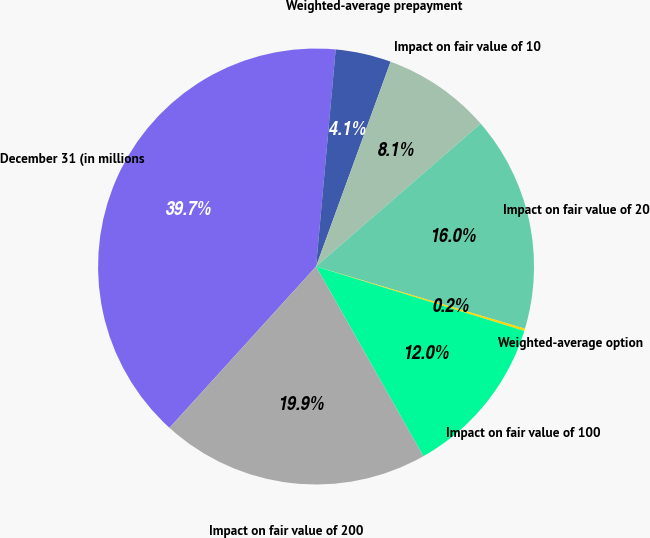Convert chart to OTSL. <chart><loc_0><loc_0><loc_500><loc_500><pie_chart><fcel>December 31 (in millions<fcel>Weighted-average prepayment<fcel>Impact on fair value of 10<fcel>Impact on fair value of 20<fcel>Weighted-average option<fcel>Impact on fair value of 100<fcel>Impact on fair value of 200<nl><fcel>39.7%<fcel>4.12%<fcel>8.07%<fcel>15.98%<fcel>0.17%<fcel>12.03%<fcel>19.93%<nl></chart> 